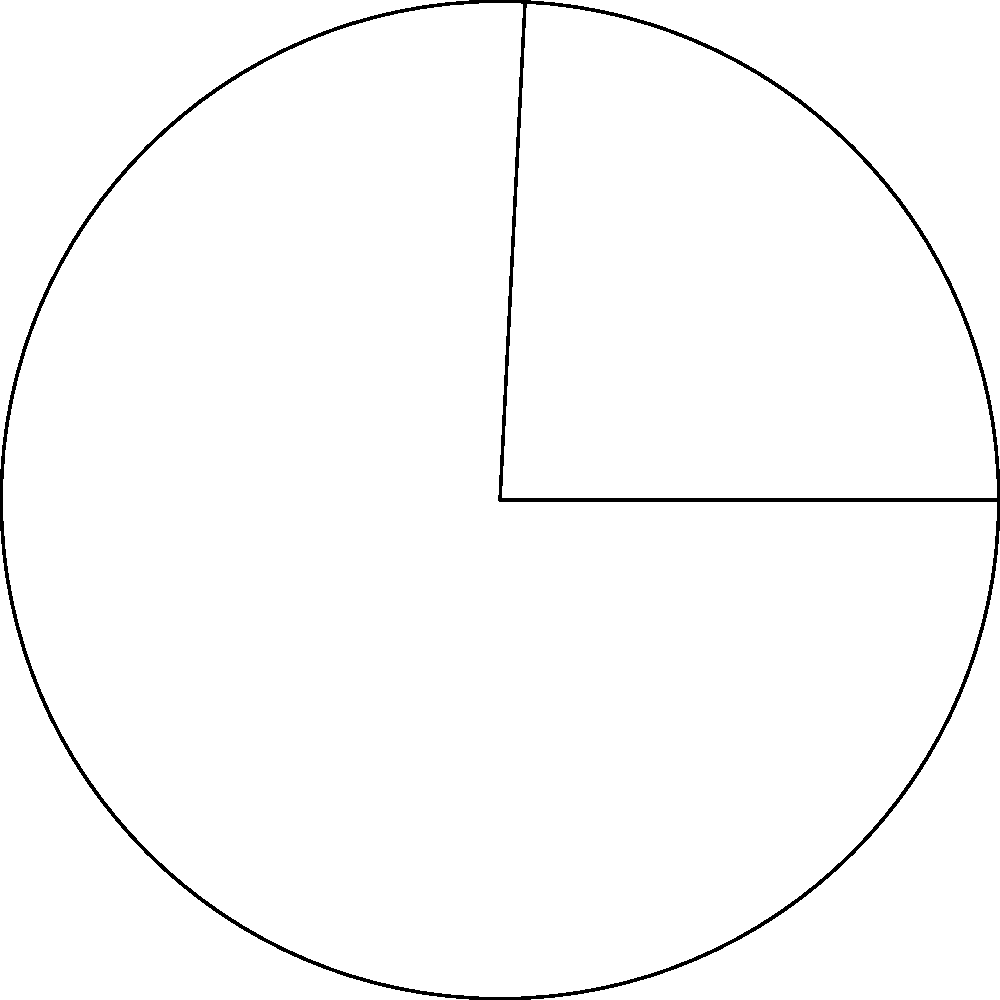Julius Erving, also known as "Dr. J", had a career average of 24.2 points per game. In honor of this statistic, consider a circular sector with a central angle of 24.2°. If the radius of the circle is 5 cm, what is the area of this sector? Round your answer to the nearest 0.01 cm². To find the area of a circular sector, we can follow these steps:

1) The formula for the area of a circular sector is:

   $$A = \frac{\theta}{360°} \pi r^2$$

   Where $\theta$ is the central angle in degrees, and $r$ is the radius.

2) We're given:
   $\theta = 24.2°$
   $r = 5$ cm

3) Let's substitute these values into our formula:

   $$A = \frac{24.2°}{360°} \pi (5 \text{ cm})^2$$

4) Simplify:
   $$A = \frac{24.2}{360} \pi (25 \text{ cm}^2)$$

5) Calculate:
   $$A \approx 0.06722 \pi (25 \text{ cm}^2)$$
   $$A \approx 1.6805 \pi \text{ cm}^2$$
   $$A \approx 5.2786 \text{ cm}^2$$

6) Rounding to the nearest 0.01 cm²:
   $$A \approx 5.28 \text{ cm}^2$$
Answer: 5.28 cm² 